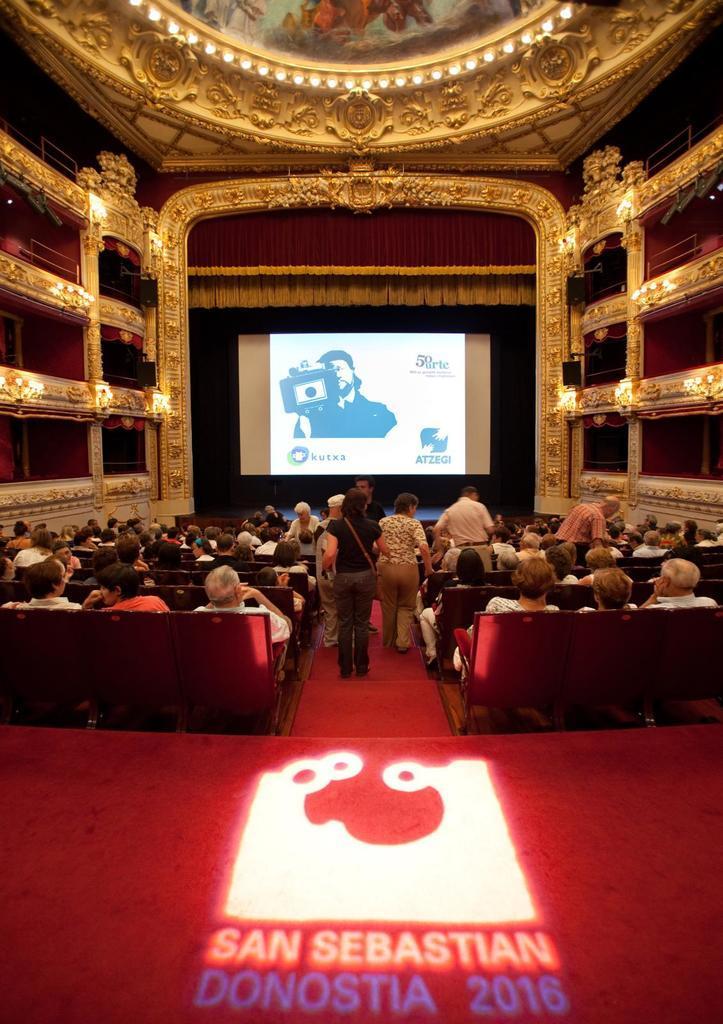Describe this image in one or two sentences. This is an inside view of a hall. In this image I can see many people are sitting facing towards the back side. In the background there is a screen. Few people are standing on the floor. At the bottom, I can see a red color mat. 